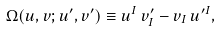Convert formula to latex. <formula><loc_0><loc_0><loc_500><loc_500>\Omega ( u , v ; u ^ { \prime } , v ^ { \prime } ) \equiv u ^ { I } \, v _ { I } ^ { \prime } - v _ { I } \, u ^ { \prime I } ,</formula> 